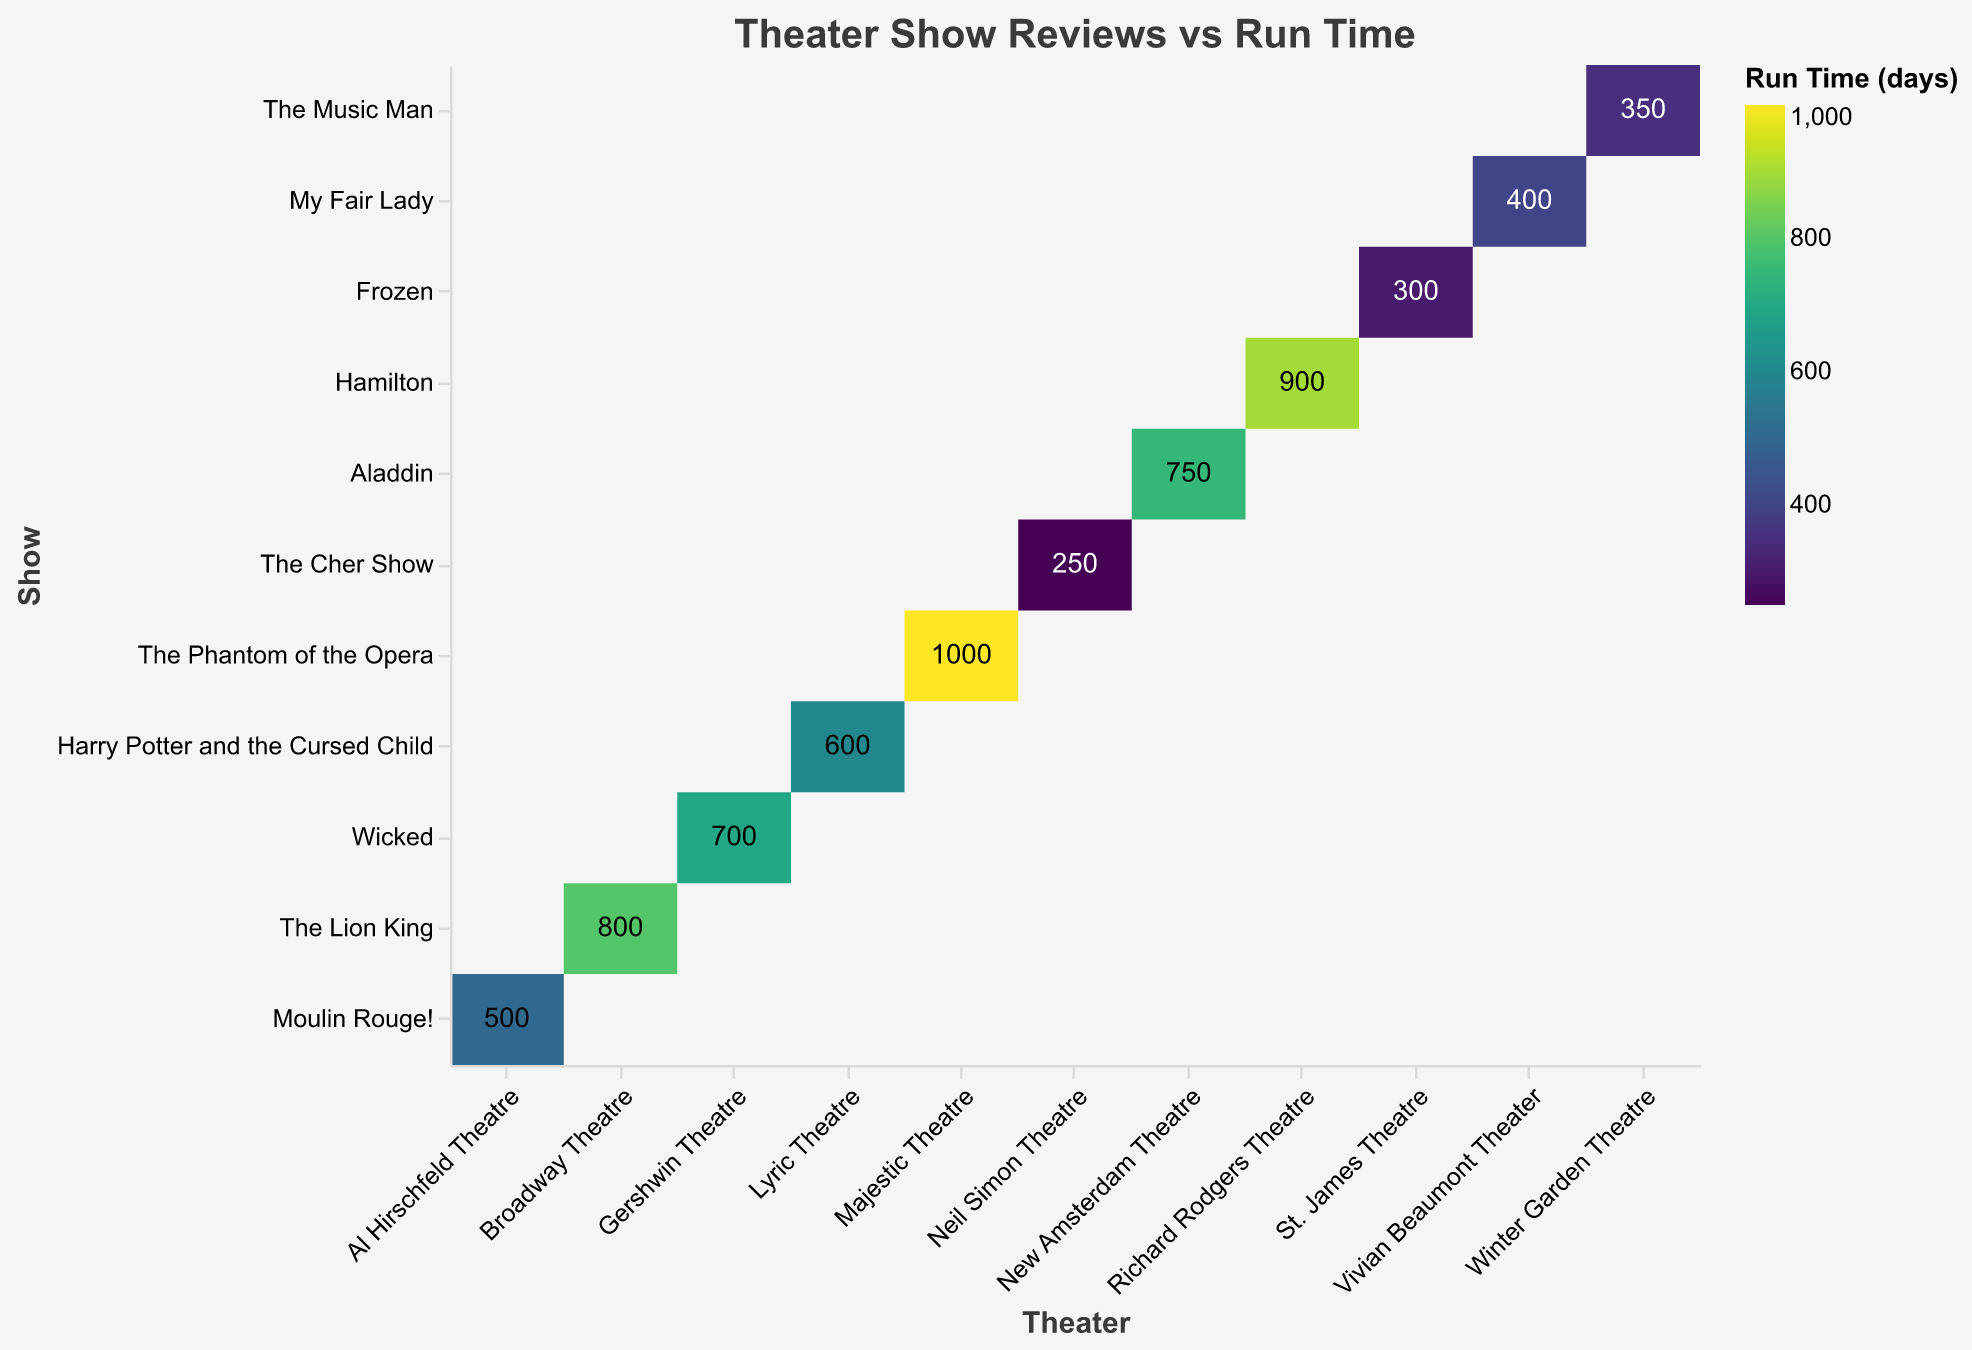What is the title of the heatmap? The title of the heatmap is displayed at the top center of the figure. It reads "Theater Show Reviews vs Run Time".
Answer: Theater Show Reviews vs Run Time Which show has the longest run time? The longest run time is shown by the darkest color in the heatmap rectangles with the highest numerical value. "The Phantom of the Opera" has a run time of 1000 days.
Answer: The Phantom of the Opera How does the run time of "Frozen" compare to "Hamilton"? "Frozen" has a run time of 300 days, which is shorter compared to "Hamilton" with a run time of 900 days.
Answer: Frozen has a shorter run time than Hamilton Which theater has the show with the shortest run time? Look for the show with the lightest color and lowest numerical value. "The Cher Show" at the Neil Simon Theatre has the shortest run time with 250 days.
Answer: Neil Simon Theatre Which show has the highest NY Times review score? The show with the highest NY Times review score can be identified by finding the highest score in the "NY Times Review" data. "Hamilton" has the highest NY Times review score of 9.5.
Answer: Hamilton What's the average run time of shows at the New Amsterdam Theatre and Lyric Theatre? The run times are 750 days at New Amsterdam Theatre and 600 days at Lyric Theatre. Average these by summing (750 + 600) = 1350 and then dividing by 2: 1350/2 = 675.
Answer: 675 days Which show at the Gershwin Theatre has a higher "USA Today Review" score than the show at the Al Hirschfeld Theatre? "Wicked" at Gershwin Theatre has a "USA Today Review" score of 8.3, which is higher than "Moulin Rouge!" at Al Hirschfeld Theatre, which has a score of 8.2.
Answer: Wicked How many shows have a run time greater than 800 days? Identify shows with run times greater than 800. These are "The Lion King", "Hamilton", and "The Phantom of the Opera".
Answer: 3 shows Is there any show with both a "Time Out NY Review" score above 9 and a run time below 400 days? No show meets both criteria as the shows with high "Time Out NY Review" scores of 9 or above either have longer run times.
Answer: No What’s the average "NY Times Review" score for shows with a run time over 700 days? Shows with run times over 700 days are "The Lion King" (9), "Wicked" (8.7), "The Phantom of the Opera" (9.2), and "Hamilton" (9.5). Sum these scores (9 + 8.7 + 9.2 + 9.5) = 36.4, divided by 4 gives the average: 36.4/4 = 9.1.
Answer: 9.1 